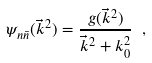<formula> <loc_0><loc_0><loc_500><loc_500>\psi _ { n \bar { n } } ( \vec { k } ^ { 2 } ) = \frac { g ( \vec { k } ^ { 2 } ) } { \vec { k } ^ { 2 } + k _ { 0 } ^ { 2 } } \ ,</formula> 